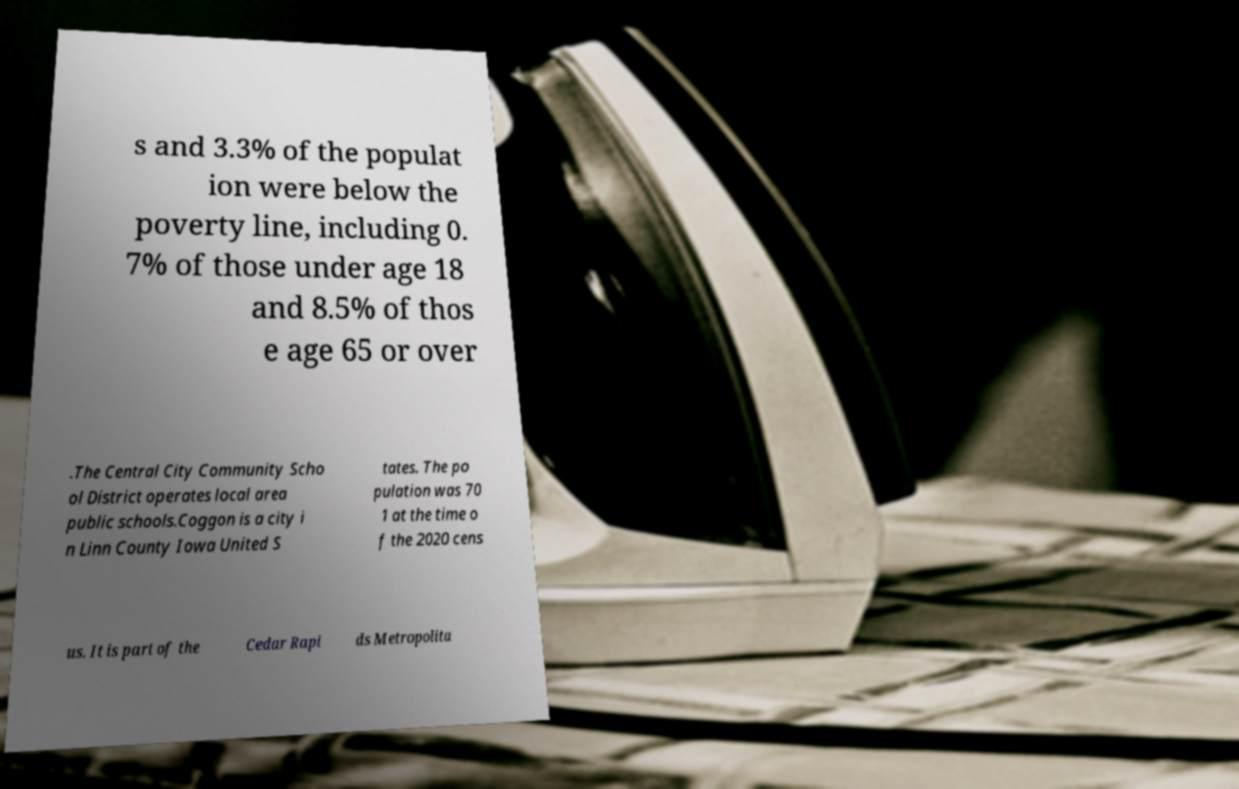Please identify and transcribe the text found in this image. s and 3.3% of the populat ion were below the poverty line, including 0. 7% of those under age 18 and 8.5% of thos e age 65 or over .The Central City Community Scho ol District operates local area public schools.Coggon is a city i n Linn County Iowa United S tates. The po pulation was 70 1 at the time o f the 2020 cens us. It is part of the Cedar Rapi ds Metropolita 